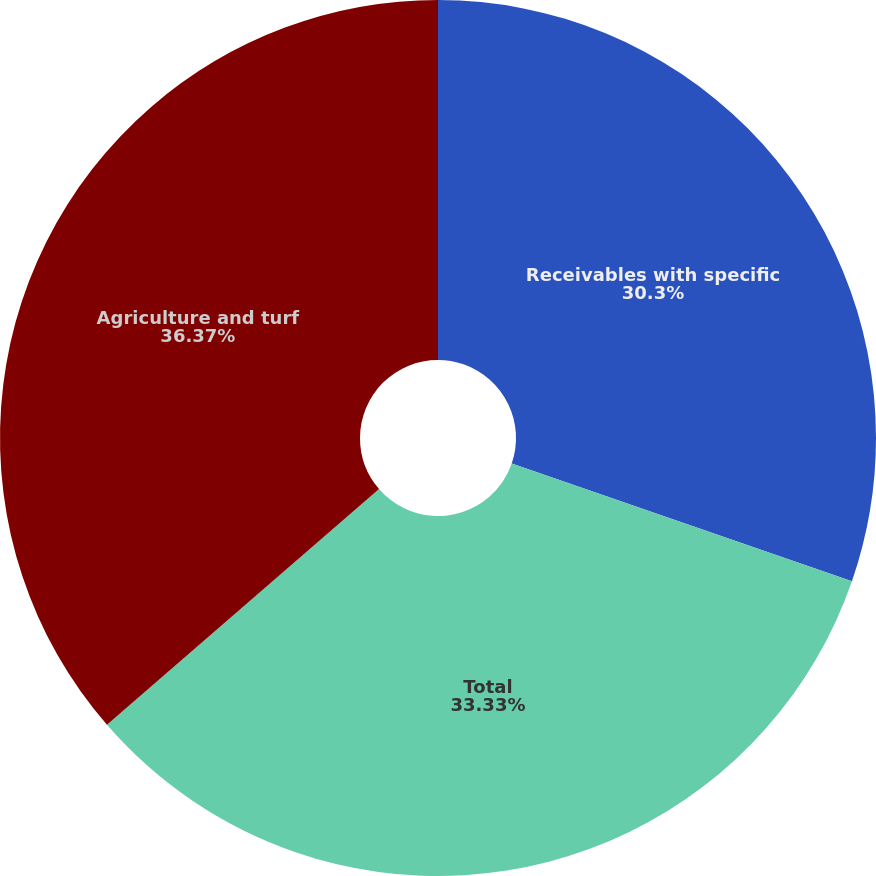Convert chart. <chart><loc_0><loc_0><loc_500><loc_500><pie_chart><fcel>Receivables with specific<fcel>Total<fcel>Agriculture and turf<nl><fcel>30.3%<fcel>33.33%<fcel>36.36%<nl></chart> 